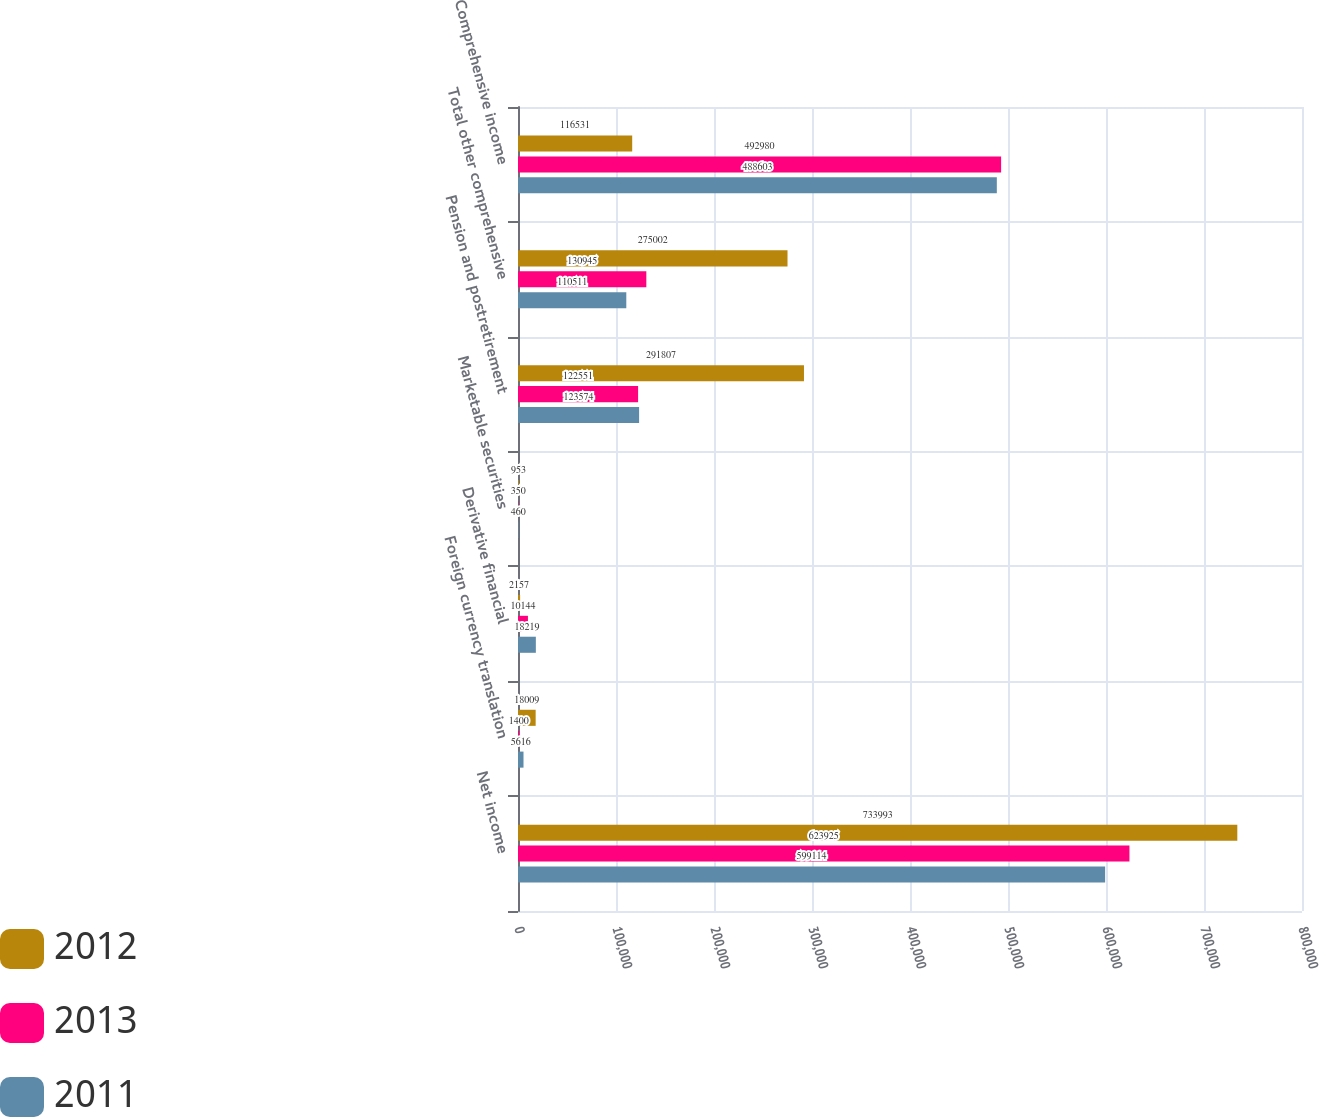<chart> <loc_0><loc_0><loc_500><loc_500><stacked_bar_chart><ecel><fcel>Net income<fcel>Foreign currency translation<fcel>Derivative financial<fcel>Marketable securities<fcel>Pension and postretirement<fcel>Total other comprehensive<fcel>Comprehensive income<nl><fcel>2012<fcel>733993<fcel>18009<fcel>2157<fcel>953<fcel>291807<fcel>275002<fcel>116531<nl><fcel>2013<fcel>623925<fcel>1400<fcel>10144<fcel>350<fcel>122551<fcel>130945<fcel>492980<nl><fcel>2011<fcel>599114<fcel>5616<fcel>18219<fcel>460<fcel>123574<fcel>110511<fcel>488603<nl></chart> 